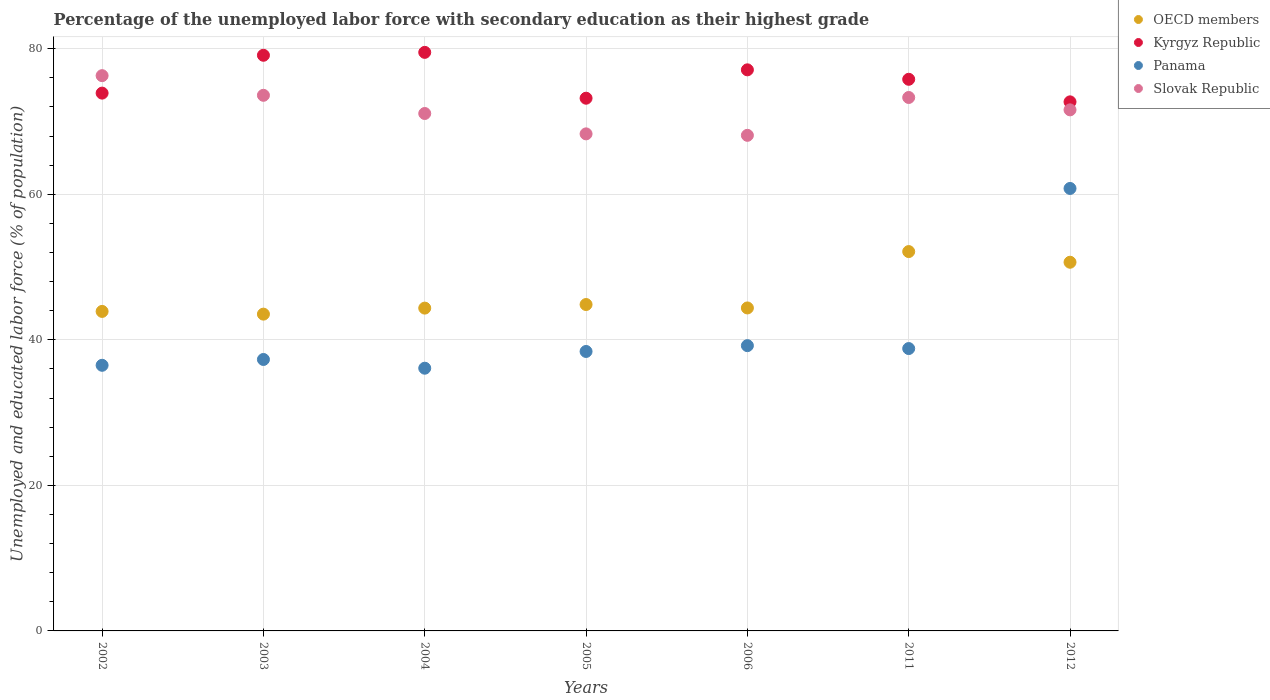How many different coloured dotlines are there?
Offer a terse response. 4. Is the number of dotlines equal to the number of legend labels?
Provide a short and direct response. Yes. What is the percentage of the unemployed labor force with secondary education in Panama in 2002?
Your answer should be very brief. 36.5. Across all years, what is the maximum percentage of the unemployed labor force with secondary education in Slovak Republic?
Offer a terse response. 76.3. Across all years, what is the minimum percentage of the unemployed labor force with secondary education in Kyrgyz Republic?
Your answer should be very brief. 72.7. What is the total percentage of the unemployed labor force with secondary education in Panama in the graph?
Your response must be concise. 287.1. What is the difference between the percentage of the unemployed labor force with secondary education in Kyrgyz Republic in 2004 and that in 2006?
Give a very brief answer. 2.4. What is the difference between the percentage of the unemployed labor force with secondary education in OECD members in 2011 and the percentage of the unemployed labor force with secondary education in Slovak Republic in 2004?
Your response must be concise. -18.97. What is the average percentage of the unemployed labor force with secondary education in OECD members per year?
Your answer should be compact. 46.26. In the year 2002, what is the difference between the percentage of the unemployed labor force with secondary education in OECD members and percentage of the unemployed labor force with secondary education in Slovak Republic?
Your response must be concise. -32.4. What is the ratio of the percentage of the unemployed labor force with secondary education in Slovak Republic in 2003 to that in 2011?
Offer a terse response. 1. Is the percentage of the unemployed labor force with secondary education in Slovak Republic in 2002 less than that in 2011?
Offer a very short reply. No. What is the difference between the highest and the second highest percentage of the unemployed labor force with secondary education in Slovak Republic?
Your answer should be compact. 2.7. What is the difference between the highest and the lowest percentage of the unemployed labor force with secondary education in Panama?
Offer a very short reply. 24.7. Is the sum of the percentage of the unemployed labor force with secondary education in Kyrgyz Republic in 2005 and 2012 greater than the maximum percentage of the unemployed labor force with secondary education in Slovak Republic across all years?
Provide a succinct answer. Yes. Is it the case that in every year, the sum of the percentage of the unemployed labor force with secondary education in OECD members and percentage of the unemployed labor force with secondary education in Slovak Republic  is greater than the percentage of the unemployed labor force with secondary education in Kyrgyz Republic?
Give a very brief answer. Yes. Does the percentage of the unemployed labor force with secondary education in Kyrgyz Republic monotonically increase over the years?
Offer a terse response. No. Is the percentage of the unemployed labor force with secondary education in Panama strictly less than the percentage of the unemployed labor force with secondary education in Kyrgyz Republic over the years?
Your response must be concise. Yes. How many years are there in the graph?
Give a very brief answer. 7. What is the difference between two consecutive major ticks on the Y-axis?
Keep it short and to the point. 20. Does the graph contain grids?
Give a very brief answer. Yes. How are the legend labels stacked?
Offer a very short reply. Vertical. What is the title of the graph?
Your answer should be compact. Percentage of the unemployed labor force with secondary education as their highest grade. Does "Australia" appear as one of the legend labels in the graph?
Provide a succinct answer. No. What is the label or title of the X-axis?
Offer a very short reply. Years. What is the label or title of the Y-axis?
Your answer should be compact. Unemployed and educated labor force (% of population). What is the Unemployed and educated labor force (% of population) of OECD members in 2002?
Provide a short and direct response. 43.9. What is the Unemployed and educated labor force (% of population) of Kyrgyz Republic in 2002?
Give a very brief answer. 73.9. What is the Unemployed and educated labor force (% of population) in Panama in 2002?
Make the answer very short. 36.5. What is the Unemployed and educated labor force (% of population) in Slovak Republic in 2002?
Your answer should be compact. 76.3. What is the Unemployed and educated labor force (% of population) of OECD members in 2003?
Your answer should be very brief. 43.53. What is the Unemployed and educated labor force (% of population) in Kyrgyz Republic in 2003?
Your response must be concise. 79.1. What is the Unemployed and educated labor force (% of population) of Panama in 2003?
Provide a short and direct response. 37.3. What is the Unemployed and educated labor force (% of population) of Slovak Republic in 2003?
Make the answer very short. 73.6. What is the Unemployed and educated labor force (% of population) of OECD members in 2004?
Your answer should be very brief. 44.36. What is the Unemployed and educated labor force (% of population) of Kyrgyz Republic in 2004?
Make the answer very short. 79.5. What is the Unemployed and educated labor force (% of population) of Panama in 2004?
Your answer should be compact. 36.1. What is the Unemployed and educated labor force (% of population) in Slovak Republic in 2004?
Your answer should be compact. 71.1. What is the Unemployed and educated labor force (% of population) in OECD members in 2005?
Your answer should be very brief. 44.85. What is the Unemployed and educated labor force (% of population) in Kyrgyz Republic in 2005?
Provide a short and direct response. 73.2. What is the Unemployed and educated labor force (% of population) in Panama in 2005?
Offer a terse response. 38.4. What is the Unemployed and educated labor force (% of population) of Slovak Republic in 2005?
Provide a succinct answer. 68.3. What is the Unemployed and educated labor force (% of population) in OECD members in 2006?
Offer a terse response. 44.38. What is the Unemployed and educated labor force (% of population) in Kyrgyz Republic in 2006?
Keep it short and to the point. 77.1. What is the Unemployed and educated labor force (% of population) of Panama in 2006?
Your response must be concise. 39.2. What is the Unemployed and educated labor force (% of population) of Slovak Republic in 2006?
Offer a very short reply. 68.1. What is the Unemployed and educated labor force (% of population) of OECD members in 2011?
Provide a short and direct response. 52.13. What is the Unemployed and educated labor force (% of population) of Kyrgyz Republic in 2011?
Your answer should be compact. 75.8. What is the Unemployed and educated labor force (% of population) in Panama in 2011?
Offer a terse response. 38.8. What is the Unemployed and educated labor force (% of population) of Slovak Republic in 2011?
Your response must be concise. 73.3. What is the Unemployed and educated labor force (% of population) of OECD members in 2012?
Ensure brevity in your answer.  50.66. What is the Unemployed and educated labor force (% of population) of Kyrgyz Republic in 2012?
Give a very brief answer. 72.7. What is the Unemployed and educated labor force (% of population) in Panama in 2012?
Give a very brief answer. 60.8. What is the Unemployed and educated labor force (% of population) in Slovak Republic in 2012?
Your response must be concise. 71.6. Across all years, what is the maximum Unemployed and educated labor force (% of population) of OECD members?
Ensure brevity in your answer.  52.13. Across all years, what is the maximum Unemployed and educated labor force (% of population) in Kyrgyz Republic?
Keep it short and to the point. 79.5. Across all years, what is the maximum Unemployed and educated labor force (% of population) in Panama?
Provide a short and direct response. 60.8. Across all years, what is the maximum Unemployed and educated labor force (% of population) of Slovak Republic?
Keep it short and to the point. 76.3. Across all years, what is the minimum Unemployed and educated labor force (% of population) in OECD members?
Make the answer very short. 43.53. Across all years, what is the minimum Unemployed and educated labor force (% of population) in Kyrgyz Republic?
Offer a very short reply. 72.7. Across all years, what is the minimum Unemployed and educated labor force (% of population) of Panama?
Your answer should be compact. 36.1. Across all years, what is the minimum Unemployed and educated labor force (% of population) of Slovak Republic?
Your answer should be compact. 68.1. What is the total Unemployed and educated labor force (% of population) of OECD members in the graph?
Offer a terse response. 323.81. What is the total Unemployed and educated labor force (% of population) of Kyrgyz Republic in the graph?
Ensure brevity in your answer.  531.3. What is the total Unemployed and educated labor force (% of population) of Panama in the graph?
Your response must be concise. 287.1. What is the total Unemployed and educated labor force (% of population) of Slovak Republic in the graph?
Make the answer very short. 502.3. What is the difference between the Unemployed and educated labor force (% of population) of OECD members in 2002 and that in 2003?
Your answer should be compact. 0.37. What is the difference between the Unemployed and educated labor force (% of population) of Kyrgyz Republic in 2002 and that in 2003?
Keep it short and to the point. -5.2. What is the difference between the Unemployed and educated labor force (% of population) of Panama in 2002 and that in 2003?
Offer a terse response. -0.8. What is the difference between the Unemployed and educated labor force (% of population) in Slovak Republic in 2002 and that in 2003?
Offer a very short reply. 2.7. What is the difference between the Unemployed and educated labor force (% of population) in OECD members in 2002 and that in 2004?
Your answer should be very brief. -0.45. What is the difference between the Unemployed and educated labor force (% of population) in Panama in 2002 and that in 2004?
Your answer should be very brief. 0.4. What is the difference between the Unemployed and educated labor force (% of population) of OECD members in 2002 and that in 2005?
Give a very brief answer. -0.95. What is the difference between the Unemployed and educated labor force (% of population) in Slovak Republic in 2002 and that in 2005?
Provide a short and direct response. 8. What is the difference between the Unemployed and educated labor force (% of population) of OECD members in 2002 and that in 2006?
Give a very brief answer. -0.48. What is the difference between the Unemployed and educated labor force (% of population) of Kyrgyz Republic in 2002 and that in 2006?
Your response must be concise. -3.2. What is the difference between the Unemployed and educated labor force (% of population) in Panama in 2002 and that in 2006?
Give a very brief answer. -2.7. What is the difference between the Unemployed and educated labor force (% of population) in Slovak Republic in 2002 and that in 2006?
Keep it short and to the point. 8.2. What is the difference between the Unemployed and educated labor force (% of population) in OECD members in 2002 and that in 2011?
Your response must be concise. -8.22. What is the difference between the Unemployed and educated labor force (% of population) of Kyrgyz Republic in 2002 and that in 2011?
Keep it short and to the point. -1.9. What is the difference between the Unemployed and educated labor force (% of population) in Panama in 2002 and that in 2011?
Provide a succinct answer. -2.3. What is the difference between the Unemployed and educated labor force (% of population) in Slovak Republic in 2002 and that in 2011?
Make the answer very short. 3. What is the difference between the Unemployed and educated labor force (% of population) in OECD members in 2002 and that in 2012?
Your response must be concise. -6.76. What is the difference between the Unemployed and educated labor force (% of population) in Panama in 2002 and that in 2012?
Your answer should be compact. -24.3. What is the difference between the Unemployed and educated labor force (% of population) in Slovak Republic in 2002 and that in 2012?
Ensure brevity in your answer.  4.7. What is the difference between the Unemployed and educated labor force (% of population) in OECD members in 2003 and that in 2004?
Offer a terse response. -0.83. What is the difference between the Unemployed and educated labor force (% of population) in Panama in 2003 and that in 2004?
Your answer should be very brief. 1.2. What is the difference between the Unemployed and educated labor force (% of population) of Slovak Republic in 2003 and that in 2004?
Provide a short and direct response. 2.5. What is the difference between the Unemployed and educated labor force (% of population) of OECD members in 2003 and that in 2005?
Give a very brief answer. -1.32. What is the difference between the Unemployed and educated labor force (% of population) in Kyrgyz Republic in 2003 and that in 2005?
Make the answer very short. 5.9. What is the difference between the Unemployed and educated labor force (% of population) of Panama in 2003 and that in 2005?
Your answer should be compact. -1.1. What is the difference between the Unemployed and educated labor force (% of population) in Slovak Republic in 2003 and that in 2005?
Give a very brief answer. 5.3. What is the difference between the Unemployed and educated labor force (% of population) in OECD members in 2003 and that in 2006?
Offer a terse response. -0.85. What is the difference between the Unemployed and educated labor force (% of population) in Kyrgyz Republic in 2003 and that in 2006?
Offer a terse response. 2. What is the difference between the Unemployed and educated labor force (% of population) of Panama in 2003 and that in 2006?
Keep it short and to the point. -1.9. What is the difference between the Unemployed and educated labor force (% of population) of Slovak Republic in 2003 and that in 2006?
Your response must be concise. 5.5. What is the difference between the Unemployed and educated labor force (% of population) of OECD members in 2003 and that in 2011?
Your response must be concise. -8.6. What is the difference between the Unemployed and educated labor force (% of population) in Kyrgyz Republic in 2003 and that in 2011?
Provide a short and direct response. 3.3. What is the difference between the Unemployed and educated labor force (% of population) of Panama in 2003 and that in 2011?
Ensure brevity in your answer.  -1.5. What is the difference between the Unemployed and educated labor force (% of population) of Slovak Republic in 2003 and that in 2011?
Provide a short and direct response. 0.3. What is the difference between the Unemployed and educated labor force (% of population) in OECD members in 2003 and that in 2012?
Offer a terse response. -7.13. What is the difference between the Unemployed and educated labor force (% of population) in Kyrgyz Republic in 2003 and that in 2012?
Your answer should be very brief. 6.4. What is the difference between the Unemployed and educated labor force (% of population) in Panama in 2003 and that in 2012?
Your answer should be very brief. -23.5. What is the difference between the Unemployed and educated labor force (% of population) in Slovak Republic in 2003 and that in 2012?
Keep it short and to the point. 2. What is the difference between the Unemployed and educated labor force (% of population) of OECD members in 2004 and that in 2005?
Provide a succinct answer. -0.49. What is the difference between the Unemployed and educated labor force (% of population) in Panama in 2004 and that in 2005?
Offer a terse response. -2.3. What is the difference between the Unemployed and educated labor force (% of population) in OECD members in 2004 and that in 2006?
Provide a short and direct response. -0.02. What is the difference between the Unemployed and educated labor force (% of population) of Kyrgyz Republic in 2004 and that in 2006?
Give a very brief answer. 2.4. What is the difference between the Unemployed and educated labor force (% of population) in Slovak Republic in 2004 and that in 2006?
Provide a short and direct response. 3. What is the difference between the Unemployed and educated labor force (% of population) in OECD members in 2004 and that in 2011?
Your answer should be very brief. -7.77. What is the difference between the Unemployed and educated labor force (% of population) of Kyrgyz Republic in 2004 and that in 2011?
Keep it short and to the point. 3.7. What is the difference between the Unemployed and educated labor force (% of population) in OECD members in 2004 and that in 2012?
Provide a short and direct response. -6.3. What is the difference between the Unemployed and educated labor force (% of population) of Kyrgyz Republic in 2004 and that in 2012?
Give a very brief answer. 6.8. What is the difference between the Unemployed and educated labor force (% of population) in Panama in 2004 and that in 2012?
Provide a short and direct response. -24.7. What is the difference between the Unemployed and educated labor force (% of population) in Slovak Republic in 2004 and that in 2012?
Your response must be concise. -0.5. What is the difference between the Unemployed and educated labor force (% of population) of OECD members in 2005 and that in 2006?
Offer a terse response. 0.47. What is the difference between the Unemployed and educated labor force (% of population) in Kyrgyz Republic in 2005 and that in 2006?
Provide a short and direct response. -3.9. What is the difference between the Unemployed and educated labor force (% of population) in OECD members in 2005 and that in 2011?
Provide a succinct answer. -7.28. What is the difference between the Unemployed and educated labor force (% of population) in Kyrgyz Republic in 2005 and that in 2011?
Provide a succinct answer. -2.6. What is the difference between the Unemployed and educated labor force (% of population) of Slovak Republic in 2005 and that in 2011?
Offer a terse response. -5. What is the difference between the Unemployed and educated labor force (% of population) of OECD members in 2005 and that in 2012?
Ensure brevity in your answer.  -5.81. What is the difference between the Unemployed and educated labor force (% of population) of Panama in 2005 and that in 2012?
Keep it short and to the point. -22.4. What is the difference between the Unemployed and educated labor force (% of population) of Slovak Republic in 2005 and that in 2012?
Offer a terse response. -3.3. What is the difference between the Unemployed and educated labor force (% of population) in OECD members in 2006 and that in 2011?
Give a very brief answer. -7.75. What is the difference between the Unemployed and educated labor force (% of population) in Panama in 2006 and that in 2011?
Offer a very short reply. 0.4. What is the difference between the Unemployed and educated labor force (% of population) of OECD members in 2006 and that in 2012?
Your answer should be very brief. -6.28. What is the difference between the Unemployed and educated labor force (% of population) in Panama in 2006 and that in 2012?
Your answer should be compact. -21.6. What is the difference between the Unemployed and educated labor force (% of population) of OECD members in 2011 and that in 2012?
Ensure brevity in your answer.  1.47. What is the difference between the Unemployed and educated labor force (% of population) in Panama in 2011 and that in 2012?
Offer a very short reply. -22. What is the difference between the Unemployed and educated labor force (% of population) of OECD members in 2002 and the Unemployed and educated labor force (% of population) of Kyrgyz Republic in 2003?
Offer a very short reply. -35.2. What is the difference between the Unemployed and educated labor force (% of population) in OECD members in 2002 and the Unemployed and educated labor force (% of population) in Panama in 2003?
Keep it short and to the point. 6.6. What is the difference between the Unemployed and educated labor force (% of population) in OECD members in 2002 and the Unemployed and educated labor force (% of population) in Slovak Republic in 2003?
Make the answer very short. -29.7. What is the difference between the Unemployed and educated labor force (% of population) in Kyrgyz Republic in 2002 and the Unemployed and educated labor force (% of population) in Panama in 2003?
Your answer should be compact. 36.6. What is the difference between the Unemployed and educated labor force (% of population) in Kyrgyz Republic in 2002 and the Unemployed and educated labor force (% of population) in Slovak Republic in 2003?
Your response must be concise. 0.3. What is the difference between the Unemployed and educated labor force (% of population) in Panama in 2002 and the Unemployed and educated labor force (% of population) in Slovak Republic in 2003?
Your response must be concise. -37.1. What is the difference between the Unemployed and educated labor force (% of population) of OECD members in 2002 and the Unemployed and educated labor force (% of population) of Kyrgyz Republic in 2004?
Provide a short and direct response. -35.6. What is the difference between the Unemployed and educated labor force (% of population) in OECD members in 2002 and the Unemployed and educated labor force (% of population) in Panama in 2004?
Keep it short and to the point. 7.8. What is the difference between the Unemployed and educated labor force (% of population) of OECD members in 2002 and the Unemployed and educated labor force (% of population) of Slovak Republic in 2004?
Provide a short and direct response. -27.2. What is the difference between the Unemployed and educated labor force (% of population) in Kyrgyz Republic in 2002 and the Unemployed and educated labor force (% of population) in Panama in 2004?
Make the answer very short. 37.8. What is the difference between the Unemployed and educated labor force (% of population) of Panama in 2002 and the Unemployed and educated labor force (% of population) of Slovak Republic in 2004?
Ensure brevity in your answer.  -34.6. What is the difference between the Unemployed and educated labor force (% of population) in OECD members in 2002 and the Unemployed and educated labor force (% of population) in Kyrgyz Republic in 2005?
Ensure brevity in your answer.  -29.3. What is the difference between the Unemployed and educated labor force (% of population) in OECD members in 2002 and the Unemployed and educated labor force (% of population) in Panama in 2005?
Give a very brief answer. 5.5. What is the difference between the Unemployed and educated labor force (% of population) of OECD members in 2002 and the Unemployed and educated labor force (% of population) of Slovak Republic in 2005?
Ensure brevity in your answer.  -24.4. What is the difference between the Unemployed and educated labor force (% of population) of Kyrgyz Republic in 2002 and the Unemployed and educated labor force (% of population) of Panama in 2005?
Offer a very short reply. 35.5. What is the difference between the Unemployed and educated labor force (% of population) of Panama in 2002 and the Unemployed and educated labor force (% of population) of Slovak Republic in 2005?
Provide a succinct answer. -31.8. What is the difference between the Unemployed and educated labor force (% of population) of OECD members in 2002 and the Unemployed and educated labor force (% of population) of Kyrgyz Republic in 2006?
Give a very brief answer. -33.2. What is the difference between the Unemployed and educated labor force (% of population) in OECD members in 2002 and the Unemployed and educated labor force (% of population) in Panama in 2006?
Offer a very short reply. 4.7. What is the difference between the Unemployed and educated labor force (% of population) of OECD members in 2002 and the Unemployed and educated labor force (% of population) of Slovak Republic in 2006?
Provide a short and direct response. -24.2. What is the difference between the Unemployed and educated labor force (% of population) of Kyrgyz Republic in 2002 and the Unemployed and educated labor force (% of population) of Panama in 2006?
Provide a short and direct response. 34.7. What is the difference between the Unemployed and educated labor force (% of population) of Panama in 2002 and the Unemployed and educated labor force (% of population) of Slovak Republic in 2006?
Your answer should be compact. -31.6. What is the difference between the Unemployed and educated labor force (% of population) in OECD members in 2002 and the Unemployed and educated labor force (% of population) in Kyrgyz Republic in 2011?
Offer a terse response. -31.9. What is the difference between the Unemployed and educated labor force (% of population) of OECD members in 2002 and the Unemployed and educated labor force (% of population) of Panama in 2011?
Your answer should be compact. 5.1. What is the difference between the Unemployed and educated labor force (% of population) of OECD members in 2002 and the Unemployed and educated labor force (% of population) of Slovak Republic in 2011?
Ensure brevity in your answer.  -29.4. What is the difference between the Unemployed and educated labor force (% of population) in Kyrgyz Republic in 2002 and the Unemployed and educated labor force (% of population) in Panama in 2011?
Keep it short and to the point. 35.1. What is the difference between the Unemployed and educated labor force (% of population) of Kyrgyz Republic in 2002 and the Unemployed and educated labor force (% of population) of Slovak Republic in 2011?
Your response must be concise. 0.6. What is the difference between the Unemployed and educated labor force (% of population) in Panama in 2002 and the Unemployed and educated labor force (% of population) in Slovak Republic in 2011?
Ensure brevity in your answer.  -36.8. What is the difference between the Unemployed and educated labor force (% of population) of OECD members in 2002 and the Unemployed and educated labor force (% of population) of Kyrgyz Republic in 2012?
Ensure brevity in your answer.  -28.8. What is the difference between the Unemployed and educated labor force (% of population) of OECD members in 2002 and the Unemployed and educated labor force (% of population) of Panama in 2012?
Offer a very short reply. -16.9. What is the difference between the Unemployed and educated labor force (% of population) of OECD members in 2002 and the Unemployed and educated labor force (% of population) of Slovak Republic in 2012?
Provide a short and direct response. -27.7. What is the difference between the Unemployed and educated labor force (% of population) of Panama in 2002 and the Unemployed and educated labor force (% of population) of Slovak Republic in 2012?
Your response must be concise. -35.1. What is the difference between the Unemployed and educated labor force (% of population) of OECD members in 2003 and the Unemployed and educated labor force (% of population) of Kyrgyz Republic in 2004?
Provide a succinct answer. -35.97. What is the difference between the Unemployed and educated labor force (% of population) in OECD members in 2003 and the Unemployed and educated labor force (% of population) in Panama in 2004?
Offer a terse response. 7.43. What is the difference between the Unemployed and educated labor force (% of population) in OECD members in 2003 and the Unemployed and educated labor force (% of population) in Slovak Republic in 2004?
Your answer should be compact. -27.57. What is the difference between the Unemployed and educated labor force (% of population) of Kyrgyz Republic in 2003 and the Unemployed and educated labor force (% of population) of Slovak Republic in 2004?
Your response must be concise. 8. What is the difference between the Unemployed and educated labor force (% of population) of Panama in 2003 and the Unemployed and educated labor force (% of population) of Slovak Republic in 2004?
Keep it short and to the point. -33.8. What is the difference between the Unemployed and educated labor force (% of population) of OECD members in 2003 and the Unemployed and educated labor force (% of population) of Kyrgyz Republic in 2005?
Ensure brevity in your answer.  -29.67. What is the difference between the Unemployed and educated labor force (% of population) of OECD members in 2003 and the Unemployed and educated labor force (% of population) of Panama in 2005?
Give a very brief answer. 5.13. What is the difference between the Unemployed and educated labor force (% of population) of OECD members in 2003 and the Unemployed and educated labor force (% of population) of Slovak Republic in 2005?
Provide a short and direct response. -24.77. What is the difference between the Unemployed and educated labor force (% of population) of Kyrgyz Republic in 2003 and the Unemployed and educated labor force (% of population) of Panama in 2005?
Your response must be concise. 40.7. What is the difference between the Unemployed and educated labor force (% of population) in Panama in 2003 and the Unemployed and educated labor force (% of population) in Slovak Republic in 2005?
Offer a very short reply. -31. What is the difference between the Unemployed and educated labor force (% of population) of OECD members in 2003 and the Unemployed and educated labor force (% of population) of Kyrgyz Republic in 2006?
Provide a succinct answer. -33.57. What is the difference between the Unemployed and educated labor force (% of population) in OECD members in 2003 and the Unemployed and educated labor force (% of population) in Panama in 2006?
Offer a very short reply. 4.33. What is the difference between the Unemployed and educated labor force (% of population) in OECD members in 2003 and the Unemployed and educated labor force (% of population) in Slovak Republic in 2006?
Your answer should be very brief. -24.57. What is the difference between the Unemployed and educated labor force (% of population) of Kyrgyz Republic in 2003 and the Unemployed and educated labor force (% of population) of Panama in 2006?
Your response must be concise. 39.9. What is the difference between the Unemployed and educated labor force (% of population) of Kyrgyz Republic in 2003 and the Unemployed and educated labor force (% of population) of Slovak Republic in 2006?
Offer a terse response. 11. What is the difference between the Unemployed and educated labor force (% of population) of Panama in 2003 and the Unemployed and educated labor force (% of population) of Slovak Republic in 2006?
Your response must be concise. -30.8. What is the difference between the Unemployed and educated labor force (% of population) of OECD members in 2003 and the Unemployed and educated labor force (% of population) of Kyrgyz Republic in 2011?
Your answer should be compact. -32.27. What is the difference between the Unemployed and educated labor force (% of population) in OECD members in 2003 and the Unemployed and educated labor force (% of population) in Panama in 2011?
Make the answer very short. 4.73. What is the difference between the Unemployed and educated labor force (% of population) in OECD members in 2003 and the Unemployed and educated labor force (% of population) in Slovak Republic in 2011?
Offer a very short reply. -29.77. What is the difference between the Unemployed and educated labor force (% of population) in Kyrgyz Republic in 2003 and the Unemployed and educated labor force (% of population) in Panama in 2011?
Your answer should be very brief. 40.3. What is the difference between the Unemployed and educated labor force (% of population) of Kyrgyz Republic in 2003 and the Unemployed and educated labor force (% of population) of Slovak Republic in 2011?
Keep it short and to the point. 5.8. What is the difference between the Unemployed and educated labor force (% of population) in Panama in 2003 and the Unemployed and educated labor force (% of population) in Slovak Republic in 2011?
Offer a very short reply. -36. What is the difference between the Unemployed and educated labor force (% of population) in OECD members in 2003 and the Unemployed and educated labor force (% of population) in Kyrgyz Republic in 2012?
Your answer should be very brief. -29.17. What is the difference between the Unemployed and educated labor force (% of population) of OECD members in 2003 and the Unemployed and educated labor force (% of population) of Panama in 2012?
Offer a terse response. -17.27. What is the difference between the Unemployed and educated labor force (% of population) in OECD members in 2003 and the Unemployed and educated labor force (% of population) in Slovak Republic in 2012?
Offer a terse response. -28.07. What is the difference between the Unemployed and educated labor force (% of population) in Kyrgyz Republic in 2003 and the Unemployed and educated labor force (% of population) in Panama in 2012?
Make the answer very short. 18.3. What is the difference between the Unemployed and educated labor force (% of population) of Kyrgyz Republic in 2003 and the Unemployed and educated labor force (% of population) of Slovak Republic in 2012?
Offer a terse response. 7.5. What is the difference between the Unemployed and educated labor force (% of population) of Panama in 2003 and the Unemployed and educated labor force (% of population) of Slovak Republic in 2012?
Give a very brief answer. -34.3. What is the difference between the Unemployed and educated labor force (% of population) in OECD members in 2004 and the Unemployed and educated labor force (% of population) in Kyrgyz Republic in 2005?
Provide a succinct answer. -28.84. What is the difference between the Unemployed and educated labor force (% of population) of OECD members in 2004 and the Unemployed and educated labor force (% of population) of Panama in 2005?
Your answer should be very brief. 5.96. What is the difference between the Unemployed and educated labor force (% of population) in OECD members in 2004 and the Unemployed and educated labor force (% of population) in Slovak Republic in 2005?
Your answer should be very brief. -23.94. What is the difference between the Unemployed and educated labor force (% of population) in Kyrgyz Republic in 2004 and the Unemployed and educated labor force (% of population) in Panama in 2005?
Offer a very short reply. 41.1. What is the difference between the Unemployed and educated labor force (% of population) of Panama in 2004 and the Unemployed and educated labor force (% of population) of Slovak Republic in 2005?
Your response must be concise. -32.2. What is the difference between the Unemployed and educated labor force (% of population) in OECD members in 2004 and the Unemployed and educated labor force (% of population) in Kyrgyz Republic in 2006?
Offer a very short reply. -32.74. What is the difference between the Unemployed and educated labor force (% of population) of OECD members in 2004 and the Unemployed and educated labor force (% of population) of Panama in 2006?
Your response must be concise. 5.16. What is the difference between the Unemployed and educated labor force (% of population) in OECD members in 2004 and the Unemployed and educated labor force (% of population) in Slovak Republic in 2006?
Your answer should be compact. -23.74. What is the difference between the Unemployed and educated labor force (% of population) in Kyrgyz Republic in 2004 and the Unemployed and educated labor force (% of population) in Panama in 2006?
Give a very brief answer. 40.3. What is the difference between the Unemployed and educated labor force (% of population) of Kyrgyz Republic in 2004 and the Unemployed and educated labor force (% of population) of Slovak Republic in 2006?
Keep it short and to the point. 11.4. What is the difference between the Unemployed and educated labor force (% of population) of Panama in 2004 and the Unemployed and educated labor force (% of population) of Slovak Republic in 2006?
Your answer should be compact. -32. What is the difference between the Unemployed and educated labor force (% of population) in OECD members in 2004 and the Unemployed and educated labor force (% of population) in Kyrgyz Republic in 2011?
Offer a very short reply. -31.44. What is the difference between the Unemployed and educated labor force (% of population) in OECD members in 2004 and the Unemployed and educated labor force (% of population) in Panama in 2011?
Your response must be concise. 5.56. What is the difference between the Unemployed and educated labor force (% of population) of OECD members in 2004 and the Unemployed and educated labor force (% of population) of Slovak Republic in 2011?
Provide a succinct answer. -28.94. What is the difference between the Unemployed and educated labor force (% of population) of Kyrgyz Republic in 2004 and the Unemployed and educated labor force (% of population) of Panama in 2011?
Make the answer very short. 40.7. What is the difference between the Unemployed and educated labor force (% of population) of Kyrgyz Republic in 2004 and the Unemployed and educated labor force (% of population) of Slovak Republic in 2011?
Your answer should be very brief. 6.2. What is the difference between the Unemployed and educated labor force (% of population) of Panama in 2004 and the Unemployed and educated labor force (% of population) of Slovak Republic in 2011?
Keep it short and to the point. -37.2. What is the difference between the Unemployed and educated labor force (% of population) of OECD members in 2004 and the Unemployed and educated labor force (% of population) of Kyrgyz Republic in 2012?
Provide a short and direct response. -28.34. What is the difference between the Unemployed and educated labor force (% of population) of OECD members in 2004 and the Unemployed and educated labor force (% of population) of Panama in 2012?
Give a very brief answer. -16.44. What is the difference between the Unemployed and educated labor force (% of population) in OECD members in 2004 and the Unemployed and educated labor force (% of population) in Slovak Republic in 2012?
Keep it short and to the point. -27.24. What is the difference between the Unemployed and educated labor force (% of population) of Kyrgyz Republic in 2004 and the Unemployed and educated labor force (% of population) of Panama in 2012?
Ensure brevity in your answer.  18.7. What is the difference between the Unemployed and educated labor force (% of population) of Kyrgyz Republic in 2004 and the Unemployed and educated labor force (% of population) of Slovak Republic in 2012?
Provide a succinct answer. 7.9. What is the difference between the Unemployed and educated labor force (% of population) in Panama in 2004 and the Unemployed and educated labor force (% of population) in Slovak Republic in 2012?
Give a very brief answer. -35.5. What is the difference between the Unemployed and educated labor force (% of population) in OECD members in 2005 and the Unemployed and educated labor force (% of population) in Kyrgyz Republic in 2006?
Give a very brief answer. -32.25. What is the difference between the Unemployed and educated labor force (% of population) of OECD members in 2005 and the Unemployed and educated labor force (% of population) of Panama in 2006?
Provide a short and direct response. 5.65. What is the difference between the Unemployed and educated labor force (% of population) in OECD members in 2005 and the Unemployed and educated labor force (% of population) in Slovak Republic in 2006?
Give a very brief answer. -23.25. What is the difference between the Unemployed and educated labor force (% of population) of Kyrgyz Republic in 2005 and the Unemployed and educated labor force (% of population) of Slovak Republic in 2006?
Provide a short and direct response. 5.1. What is the difference between the Unemployed and educated labor force (% of population) in Panama in 2005 and the Unemployed and educated labor force (% of population) in Slovak Republic in 2006?
Provide a short and direct response. -29.7. What is the difference between the Unemployed and educated labor force (% of population) of OECD members in 2005 and the Unemployed and educated labor force (% of population) of Kyrgyz Republic in 2011?
Your response must be concise. -30.95. What is the difference between the Unemployed and educated labor force (% of population) in OECD members in 2005 and the Unemployed and educated labor force (% of population) in Panama in 2011?
Provide a short and direct response. 6.05. What is the difference between the Unemployed and educated labor force (% of population) in OECD members in 2005 and the Unemployed and educated labor force (% of population) in Slovak Republic in 2011?
Offer a terse response. -28.45. What is the difference between the Unemployed and educated labor force (% of population) of Kyrgyz Republic in 2005 and the Unemployed and educated labor force (% of population) of Panama in 2011?
Offer a terse response. 34.4. What is the difference between the Unemployed and educated labor force (% of population) in Panama in 2005 and the Unemployed and educated labor force (% of population) in Slovak Republic in 2011?
Ensure brevity in your answer.  -34.9. What is the difference between the Unemployed and educated labor force (% of population) of OECD members in 2005 and the Unemployed and educated labor force (% of population) of Kyrgyz Republic in 2012?
Provide a succinct answer. -27.85. What is the difference between the Unemployed and educated labor force (% of population) of OECD members in 2005 and the Unemployed and educated labor force (% of population) of Panama in 2012?
Keep it short and to the point. -15.95. What is the difference between the Unemployed and educated labor force (% of population) of OECD members in 2005 and the Unemployed and educated labor force (% of population) of Slovak Republic in 2012?
Provide a succinct answer. -26.75. What is the difference between the Unemployed and educated labor force (% of population) of Kyrgyz Republic in 2005 and the Unemployed and educated labor force (% of population) of Slovak Republic in 2012?
Give a very brief answer. 1.6. What is the difference between the Unemployed and educated labor force (% of population) of Panama in 2005 and the Unemployed and educated labor force (% of population) of Slovak Republic in 2012?
Your response must be concise. -33.2. What is the difference between the Unemployed and educated labor force (% of population) of OECD members in 2006 and the Unemployed and educated labor force (% of population) of Kyrgyz Republic in 2011?
Keep it short and to the point. -31.42. What is the difference between the Unemployed and educated labor force (% of population) in OECD members in 2006 and the Unemployed and educated labor force (% of population) in Panama in 2011?
Your response must be concise. 5.58. What is the difference between the Unemployed and educated labor force (% of population) of OECD members in 2006 and the Unemployed and educated labor force (% of population) of Slovak Republic in 2011?
Offer a terse response. -28.92. What is the difference between the Unemployed and educated labor force (% of population) of Kyrgyz Republic in 2006 and the Unemployed and educated labor force (% of population) of Panama in 2011?
Keep it short and to the point. 38.3. What is the difference between the Unemployed and educated labor force (% of population) of Kyrgyz Republic in 2006 and the Unemployed and educated labor force (% of population) of Slovak Republic in 2011?
Keep it short and to the point. 3.8. What is the difference between the Unemployed and educated labor force (% of population) of Panama in 2006 and the Unemployed and educated labor force (% of population) of Slovak Republic in 2011?
Provide a succinct answer. -34.1. What is the difference between the Unemployed and educated labor force (% of population) in OECD members in 2006 and the Unemployed and educated labor force (% of population) in Kyrgyz Republic in 2012?
Offer a terse response. -28.32. What is the difference between the Unemployed and educated labor force (% of population) of OECD members in 2006 and the Unemployed and educated labor force (% of population) of Panama in 2012?
Make the answer very short. -16.42. What is the difference between the Unemployed and educated labor force (% of population) in OECD members in 2006 and the Unemployed and educated labor force (% of population) in Slovak Republic in 2012?
Your response must be concise. -27.22. What is the difference between the Unemployed and educated labor force (% of population) of Kyrgyz Republic in 2006 and the Unemployed and educated labor force (% of population) of Slovak Republic in 2012?
Provide a succinct answer. 5.5. What is the difference between the Unemployed and educated labor force (% of population) in Panama in 2006 and the Unemployed and educated labor force (% of population) in Slovak Republic in 2012?
Give a very brief answer. -32.4. What is the difference between the Unemployed and educated labor force (% of population) of OECD members in 2011 and the Unemployed and educated labor force (% of population) of Kyrgyz Republic in 2012?
Make the answer very short. -20.57. What is the difference between the Unemployed and educated labor force (% of population) in OECD members in 2011 and the Unemployed and educated labor force (% of population) in Panama in 2012?
Make the answer very short. -8.67. What is the difference between the Unemployed and educated labor force (% of population) of OECD members in 2011 and the Unemployed and educated labor force (% of population) of Slovak Republic in 2012?
Ensure brevity in your answer.  -19.47. What is the difference between the Unemployed and educated labor force (% of population) of Panama in 2011 and the Unemployed and educated labor force (% of population) of Slovak Republic in 2012?
Ensure brevity in your answer.  -32.8. What is the average Unemployed and educated labor force (% of population) of OECD members per year?
Your answer should be compact. 46.26. What is the average Unemployed and educated labor force (% of population) of Kyrgyz Republic per year?
Give a very brief answer. 75.9. What is the average Unemployed and educated labor force (% of population) in Panama per year?
Provide a succinct answer. 41.01. What is the average Unemployed and educated labor force (% of population) of Slovak Republic per year?
Offer a terse response. 71.76. In the year 2002, what is the difference between the Unemployed and educated labor force (% of population) of OECD members and Unemployed and educated labor force (% of population) of Kyrgyz Republic?
Offer a very short reply. -30. In the year 2002, what is the difference between the Unemployed and educated labor force (% of population) of OECD members and Unemployed and educated labor force (% of population) of Panama?
Offer a terse response. 7.4. In the year 2002, what is the difference between the Unemployed and educated labor force (% of population) in OECD members and Unemployed and educated labor force (% of population) in Slovak Republic?
Give a very brief answer. -32.4. In the year 2002, what is the difference between the Unemployed and educated labor force (% of population) of Kyrgyz Republic and Unemployed and educated labor force (% of population) of Panama?
Your answer should be very brief. 37.4. In the year 2002, what is the difference between the Unemployed and educated labor force (% of population) of Panama and Unemployed and educated labor force (% of population) of Slovak Republic?
Ensure brevity in your answer.  -39.8. In the year 2003, what is the difference between the Unemployed and educated labor force (% of population) in OECD members and Unemployed and educated labor force (% of population) in Kyrgyz Republic?
Provide a short and direct response. -35.57. In the year 2003, what is the difference between the Unemployed and educated labor force (% of population) of OECD members and Unemployed and educated labor force (% of population) of Panama?
Make the answer very short. 6.23. In the year 2003, what is the difference between the Unemployed and educated labor force (% of population) in OECD members and Unemployed and educated labor force (% of population) in Slovak Republic?
Give a very brief answer. -30.07. In the year 2003, what is the difference between the Unemployed and educated labor force (% of population) of Kyrgyz Republic and Unemployed and educated labor force (% of population) of Panama?
Offer a terse response. 41.8. In the year 2003, what is the difference between the Unemployed and educated labor force (% of population) in Kyrgyz Republic and Unemployed and educated labor force (% of population) in Slovak Republic?
Offer a very short reply. 5.5. In the year 2003, what is the difference between the Unemployed and educated labor force (% of population) of Panama and Unemployed and educated labor force (% of population) of Slovak Republic?
Keep it short and to the point. -36.3. In the year 2004, what is the difference between the Unemployed and educated labor force (% of population) in OECD members and Unemployed and educated labor force (% of population) in Kyrgyz Republic?
Your response must be concise. -35.14. In the year 2004, what is the difference between the Unemployed and educated labor force (% of population) of OECD members and Unemployed and educated labor force (% of population) of Panama?
Keep it short and to the point. 8.26. In the year 2004, what is the difference between the Unemployed and educated labor force (% of population) of OECD members and Unemployed and educated labor force (% of population) of Slovak Republic?
Ensure brevity in your answer.  -26.74. In the year 2004, what is the difference between the Unemployed and educated labor force (% of population) in Kyrgyz Republic and Unemployed and educated labor force (% of population) in Panama?
Provide a succinct answer. 43.4. In the year 2004, what is the difference between the Unemployed and educated labor force (% of population) in Kyrgyz Republic and Unemployed and educated labor force (% of population) in Slovak Republic?
Provide a short and direct response. 8.4. In the year 2004, what is the difference between the Unemployed and educated labor force (% of population) of Panama and Unemployed and educated labor force (% of population) of Slovak Republic?
Give a very brief answer. -35. In the year 2005, what is the difference between the Unemployed and educated labor force (% of population) in OECD members and Unemployed and educated labor force (% of population) in Kyrgyz Republic?
Provide a succinct answer. -28.35. In the year 2005, what is the difference between the Unemployed and educated labor force (% of population) of OECD members and Unemployed and educated labor force (% of population) of Panama?
Your answer should be compact. 6.45. In the year 2005, what is the difference between the Unemployed and educated labor force (% of population) in OECD members and Unemployed and educated labor force (% of population) in Slovak Republic?
Ensure brevity in your answer.  -23.45. In the year 2005, what is the difference between the Unemployed and educated labor force (% of population) in Kyrgyz Republic and Unemployed and educated labor force (% of population) in Panama?
Offer a terse response. 34.8. In the year 2005, what is the difference between the Unemployed and educated labor force (% of population) in Panama and Unemployed and educated labor force (% of population) in Slovak Republic?
Make the answer very short. -29.9. In the year 2006, what is the difference between the Unemployed and educated labor force (% of population) in OECD members and Unemployed and educated labor force (% of population) in Kyrgyz Republic?
Make the answer very short. -32.72. In the year 2006, what is the difference between the Unemployed and educated labor force (% of population) of OECD members and Unemployed and educated labor force (% of population) of Panama?
Your answer should be compact. 5.18. In the year 2006, what is the difference between the Unemployed and educated labor force (% of population) of OECD members and Unemployed and educated labor force (% of population) of Slovak Republic?
Your answer should be compact. -23.72. In the year 2006, what is the difference between the Unemployed and educated labor force (% of population) of Kyrgyz Republic and Unemployed and educated labor force (% of population) of Panama?
Offer a terse response. 37.9. In the year 2006, what is the difference between the Unemployed and educated labor force (% of population) in Panama and Unemployed and educated labor force (% of population) in Slovak Republic?
Offer a terse response. -28.9. In the year 2011, what is the difference between the Unemployed and educated labor force (% of population) in OECD members and Unemployed and educated labor force (% of population) in Kyrgyz Republic?
Your answer should be compact. -23.67. In the year 2011, what is the difference between the Unemployed and educated labor force (% of population) in OECD members and Unemployed and educated labor force (% of population) in Panama?
Your answer should be very brief. 13.33. In the year 2011, what is the difference between the Unemployed and educated labor force (% of population) in OECD members and Unemployed and educated labor force (% of population) in Slovak Republic?
Keep it short and to the point. -21.17. In the year 2011, what is the difference between the Unemployed and educated labor force (% of population) in Panama and Unemployed and educated labor force (% of population) in Slovak Republic?
Keep it short and to the point. -34.5. In the year 2012, what is the difference between the Unemployed and educated labor force (% of population) in OECD members and Unemployed and educated labor force (% of population) in Kyrgyz Republic?
Provide a succinct answer. -22.04. In the year 2012, what is the difference between the Unemployed and educated labor force (% of population) of OECD members and Unemployed and educated labor force (% of population) of Panama?
Your response must be concise. -10.14. In the year 2012, what is the difference between the Unemployed and educated labor force (% of population) of OECD members and Unemployed and educated labor force (% of population) of Slovak Republic?
Your response must be concise. -20.94. In the year 2012, what is the difference between the Unemployed and educated labor force (% of population) of Kyrgyz Republic and Unemployed and educated labor force (% of population) of Slovak Republic?
Provide a succinct answer. 1.1. In the year 2012, what is the difference between the Unemployed and educated labor force (% of population) in Panama and Unemployed and educated labor force (% of population) in Slovak Republic?
Your response must be concise. -10.8. What is the ratio of the Unemployed and educated labor force (% of population) in OECD members in 2002 to that in 2003?
Provide a short and direct response. 1.01. What is the ratio of the Unemployed and educated labor force (% of population) of Kyrgyz Republic in 2002 to that in 2003?
Provide a succinct answer. 0.93. What is the ratio of the Unemployed and educated labor force (% of population) in Panama in 2002 to that in 2003?
Offer a terse response. 0.98. What is the ratio of the Unemployed and educated labor force (% of population) in Slovak Republic in 2002 to that in 2003?
Ensure brevity in your answer.  1.04. What is the ratio of the Unemployed and educated labor force (% of population) in OECD members in 2002 to that in 2004?
Provide a short and direct response. 0.99. What is the ratio of the Unemployed and educated labor force (% of population) of Kyrgyz Republic in 2002 to that in 2004?
Give a very brief answer. 0.93. What is the ratio of the Unemployed and educated labor force (% of population) in Panama in 2002 to that in 2004?
Offer a very short reply. 1.01. What is the ratio of the Unemployed and educated labor force (% of population) of Slovak Republic in 2002 to that in 2004?
Offer a terse response. 1.07. What is the ratio of the Unemployed and educated labor force (% of population) of OECD members in 2002 to that in 2005?
Provide a succinct answer. 0.98. What is the ratio of the Unemployed and educated labor force (% of population) of Kyrgyz Republic in 2002 to that in 2005?
Provide a short and direct response. 1.01. What is the ratio of the Unemployed and educated labor force (% of population) of Panama in 2002 to that in 2005?
Your answer should be compact. 0.95. What is the ratio of the Unemployed and educated labor force (% of population) of Slovak Republic in 2002 to that in 2005?
Provide a short and direct response. 1.12. What is the ratio of the Unemployed and educated labor force (% of population) in OECD members in 2002 to that in 2006?
Offer a very short reply. 0.99. What is the ratio of the Unemployed and educated labor force (% of population) in Kyrgyz Republic in 2002 to that in 2006?
Give a very brief answer. 0.96. What is the ratio of the Unemployed and educated labor force (% of population) in Panama in 2002 to that in 2006?
Provide a succinct answer. 0.93. What is the ratio of the Unemployed and educated labor force (% of population) in Slovak Republic in 2002 to that in 2006?
Your answer should be very brief. 1.12. What is the ratio of the Unemployed and educated labor force (% of population) in OECD members in 2002 to that in 2011?
Give a very brief answer. 0.84. What is the ratio of the Unemployed and educated labor force (% of population) in Kyrgyz Republic in 2002 to that in 2011?
Provide a short and direct response. 0.97. What is the ratio of the Unemployed and educated labor force (% of population) in Panama in 2002 to that in 2011?
Offer a terse response. 0.94. What is the ratio of the Unemployed and educated labor force (% of population) of Slovak Republic in 2002 to that in 2011?
Offer a very short reply. 1.04. What is the ratio of the Unemployed and educated labor force (% of population) of OECD members in 2002 to that in 2012?
Offer a very short reply. 0.87. What is the ratio of the Unemployed and educated labor force (% of population) of Kyrgyz Republic in 2002 to that in 2012?
Provide a short and direct response. 1.02. What is the ratio of the Unemployed and educated labor force (% of population) in Panama in 2002 to that in 2012?
Provide a succinct answer. 0.6. What is the ratio of the Unemployed and educated labor force (% of population) of Slovak Republic in 2002 to that in 2012?
Keep it short and to the point. 1.07. What is the ratio of the Unemployed and educated labor force (% of population) of OECD members in 2003 to that in 2004?
Offer a very short reply. 0.98. What is the ratio of the Unemployed and educated labor force (% of population) in Kyrgyz Republic in 2003 to that in 2004?
Give a very brief answer. 0.99. What is the ratio of the Unemployed and educated labor force (% of population) in Panama in 2003 to that in 2004?
Give a very brief answer. 1.03. What is the ratio of the Unemployed and educated labor force (% of population) of Slovak Republic in 2003 to that in 2004?
Provide a succinct answer. 1.04. What is the ratio of the Unemployed and educated labor force (% of population) in OECD members in 2003 to that in 2005?
Your answer should be very brief. 0.97. What is the ratio of the Unemployed and educated labor force (% of population) of Kyrgyz Republic in 2003 to that in 2005?
Your answer should be very brief. 1.08. What is the ratio of the Unemployed and educated labor force (% of population) in Panama in 2003 to that in 2005?
Your response must be concise. 0.97. What is the ratio of the Unemployed and educated labor force (% of population) of Slovak Republic in 2003 to that in 2005?
Your response must be concise. 1.08. What is the ratio of the Unemployed and educated labor force (% of population) of OECD members in 2003 to that in 2006?
Your response must be concise. 0.98. What is the ratio of the Unemployed and educated labor force (% of population) in Kyrgyz Republic in 2003 to that in 2006?
Provide a short and direct response. 1.03. What is the ratio of the Unemployed and educated labor force (% of population) in Panama in 2003 to that in 2006?
Provide a succinct answer. 0.95. What is the ratio of the Unemployed and educated labor force (% of population) in Slovak Republic in 2003 to that in 2006?
Your answer should be very brief. 1.08. What is the ratio of the Unemployed and educated labor force (% of population) in OECD members in 2003 to that in 2011?
Your answer should be compact. 0.84. What is the ratio of the Unemployed and educated labor force (% of population) of Kyrgyz Republic in 2003 to that in 2011?
Your answer should be compact. 1.04. What is the ratio of the Unemployed and educated labor force (% of population) of Panama in 2003 to that in 2011?
Offer a terse response. 0.96. What is the ratio of the Unemployed and educated labor force (% of population) of Slovak Republic in 2003 to that in 2011?
Make the answer very short. 1. What is the ratio of the Unemployed and educated labor force (% of population) of OECD members in 2003 to that in 2012?
Offer a terse response. 0.86. What is the ratio of the Unemployed and educated labor force (% of population) in Kyrgyz Republic in 2003 to that in 2012?
Ensure brevity in your answer.  1.09. What is the ratio of the Unemployed and educated labor force (% of population) in Panama in 2003 to that in 2012?
Your response must be concise. 0.61. What is the ratio of the Unemployed and educated labor force (% of population) in Slovak Republic in 2003 to that in 2012?
Provide a short and direct response. 1.03. What is the ratio of the Unemployed and educated labor force (% of population) in Kyrgyz Republic in 2004 to that in 2005?
Keep it short and to the point. 1.09. What is the ratio of the Unemployed and educated labor force (% of population) in Panama in 2004 to that in 2005?
Offer a very short reply. 0.94. What is the ratio of the Unemployed and educated labor force (% of population) of Slovak Republic in 2004 to that in 2005?
Keep it short and to the point. 1.04. What is the ratio of the Unemployed and educated labor force (% of population) of OECD members in 2004 to that in 2006?
Provide a succinct answer. 1. What is the ratio of the Unemployed and educated labor force (% of population) in Kyrgyz Republic in 2004 to that in 2006?
Provide a succinct answer. 1.03. What is the ratio of the Unemployed and educated labor force (% of population) of Panama in 2004 to that in 2006?
Provide a short and direct response. 0.92. What is the ratio of the Unemployed and educated labor force (% of population) in Slovak Republic in 2004 to that in 2006?
Your answer should be compact. 1.04. What is the ratio of the Unemployed and educated labor force (% of population) of OECD members in 2004 to that in 2011?
Offer a terse response. 0.85. What is the ratio of the Unemployed and educated labor force (% of population) of Kyrgyz Republic in 2004 to that in 2011?
Give a very brief answer. 1.05. What is the ratio of the Unemployed and educated labor force (% of population) of Panama in 2004 to that in 2011?
Provide a short and direct response. 0.93. What is the ratio of the Unemployed and educated labor force (% of population) in Slovak Republic in 2004 to that in 2011?
Your answer should be very brief. 0.97. What is the ratio of the Unemployed and educated labor force (% of population) in OECD members in 2004 to that in 2012?
Give a very brief answer. 0.88. What is the ratio of the Unemployed and educated labor force (% of population) of Kyrgyz Republic in 2004 to that in 2012?
Your response must be concise. 1.09. What is the ratio of the Unemployed and educated labor force (% of population) in Panama in 2004 to that in 2012?
Offer a very short reply. 0.59. What is the ratio of the Unemployed and educated labor force (% of population) in OECD members in 2005 to that in 2006?
Give a very brief answer. 1.01. What is the ratio of the Unemployed and educated labor force (% of population) of Kyrgyz Republic in 2005 to that in 2006?
Your answer should be compact. 0.95. What is the ratio of the Unemployed and educated labor force (% of population) in Panama in 2005 to that in 2006?
Your answer should be very brief. 0.98. What is the ratio of the Unemployed and educated labor force (% of population) in OECD members in 2005 to that in 2011?
Ensure brevity in your answer.  0.86. What is the ratio of the Unemployed and educated labor force (% of population) of Kyrgyz Republic in 2005 to that in 2011?
Give a very brief answer. 0.97. What is the ratio of the Unemployed and educated labor force (% of population) of Panama in 2005 to that in 2011?
Offer a terse response. 0.99. What is the ratio of the Unemployed and educated labor force (% of population) in Slovak Republic in 2005 to that in 2011?
Give a very brief answer. 0.93. What is the ratio of the Unemployed and educated labor force (% of population) in OECD members in 2005 to that in 2012?
Make the answer very short. 0.89. What is the ratio of the Unemployed and educated labor force (% of population) of Panama in 2005 to that in 2012?
Make the answer very short. 0.63. What is the ratio of the Unemployed and educated labor force (% of population) in Slovak Republic in 2005 to that in 2012?
Ensure brevity in your answer.  0.95. What is the ratio of the Unemployed and educated labor force (% of population) in OECD members in 2006 to that in 2011?
Ensure brevity in your answer.  0.85. What is the ratio of the Unemployed and educated labor force (% of population) of Kyrgyz Republic in 2006 to that in 2011?
Offer a terse response. 1.02. What is the ratio of the Unemployed and educated labor force (% of population) in Panama in 2006 to that in 2011?
Your answer should be compact. 1.01. What is the ratio of the Unemployed and educated labor force (% of population) of Slovak Republic in 2006 to that in 2011?
Your answer should be very brief. 0.93. What is the ratio of the Unemployed and educated labor force (% of population) of OECD members in 2006 to that in 2012?
Your answer should be very brief. 0.88. What is the ratio of the Unemployed and educated labor force (% of population) in Kyrgyz Republic in 2006 to that in 2012?
Offer a very short reply. 1.06. What is the ratio of the Unemployed and educated labor force (% of population) in Panama in 2006 to that in 2012?
Offer a very short reply. 0.64. What is the ratio of the Unemployed and educated labor force (% of population) of Slovak Republic in 2006 to that in 2012?
Keep it short and to the point. 0.95. What is the ratio of the Unemployed and educated labor force (% of population) in OECD members in 2011 to that in 2012?
Make the answer very short. 1.03. What is the ratio of the Unemployed and educated labor force (% of population) in Kyrgyz Republic in 2011 to that in 2012?
Provide a short and direct response. 1.04. What is the ratio of the Unemployed and educated labor force (% of population) in Panama in 2011 to that in 2012?
Make the answer very short. 0.64. What is the ratio of the Unemployed and educated labor force (% of population) in Slovak Republic in 2011 to that in 2012?
Your answer should be compact. 1.02. What is the difference between the highest and the second highest Unemployed and educated labor force (% of population) in OECD members?
Offer a very short reply. 1.47. What is the difference between the highest and the second highest Unemployed and educated labor force (% of population) in Kyrgyz Republic?
Provide a succinct answer. 0.4. What is the difference between the highest and the second highest Unemployed and educated labor force (% of population) of Panama?
Keep it short and to the point. 21.6. What is the difference between the highest and the second highest Unemployed and educated labor force (% of population) in Slovak Republic?
Keep it short and to the point. 2.7. What is the difference between the highest and the lowest Unemployed and educated labor force (% of population) of OECD members?
Keep it short and to the point. 8.6. What is the difference between the highest and the lowest Unemployed and educated labor force (% of population) in Panama?
Ensure brevity in your answer.  24.7. What is the difference between the highest and the lowest Unemployed and educated labor force (% of population) in Slovak Republic?
Offer a terse response. 8.2. 